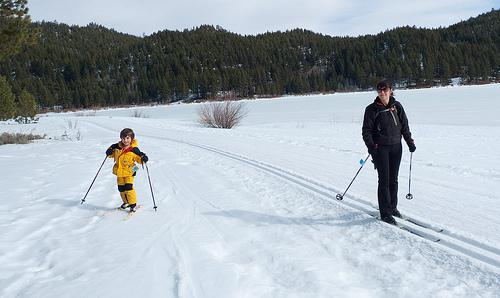Question: what are these people doing?
Choices:
A. Dancing.
B. Polka.
C. Skiing.
D. Crawling.
Answer with the letter. Answer: C Question: what color is the boy's ski suit?
Choices:
A. White.
B. Yellow.
C. Red.
D. Black.
Answer with the letter. Answer: B Question: what are the skiers standing on?
Choices:
A. Snow.
B. Top of ski run.
C. Skis.
D. Porch of lodge.
Answer with the letter. Answer: A Question: why are they skiing?
Choices:
A. Competing for medals.
B. To get a good score.
C. It's fun.
D. Racing.
Answer with the letter. Answer: C Question: when was this photo taken?
Choices:
A. Wintertime.
B. Wwii.
C. Before the ceremony.
D. After brunch.
Answer with the letter. Answer: A 